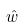<formula> <loc_0><loc_0><loc_500><loc_500>\hat { w }</formula> 